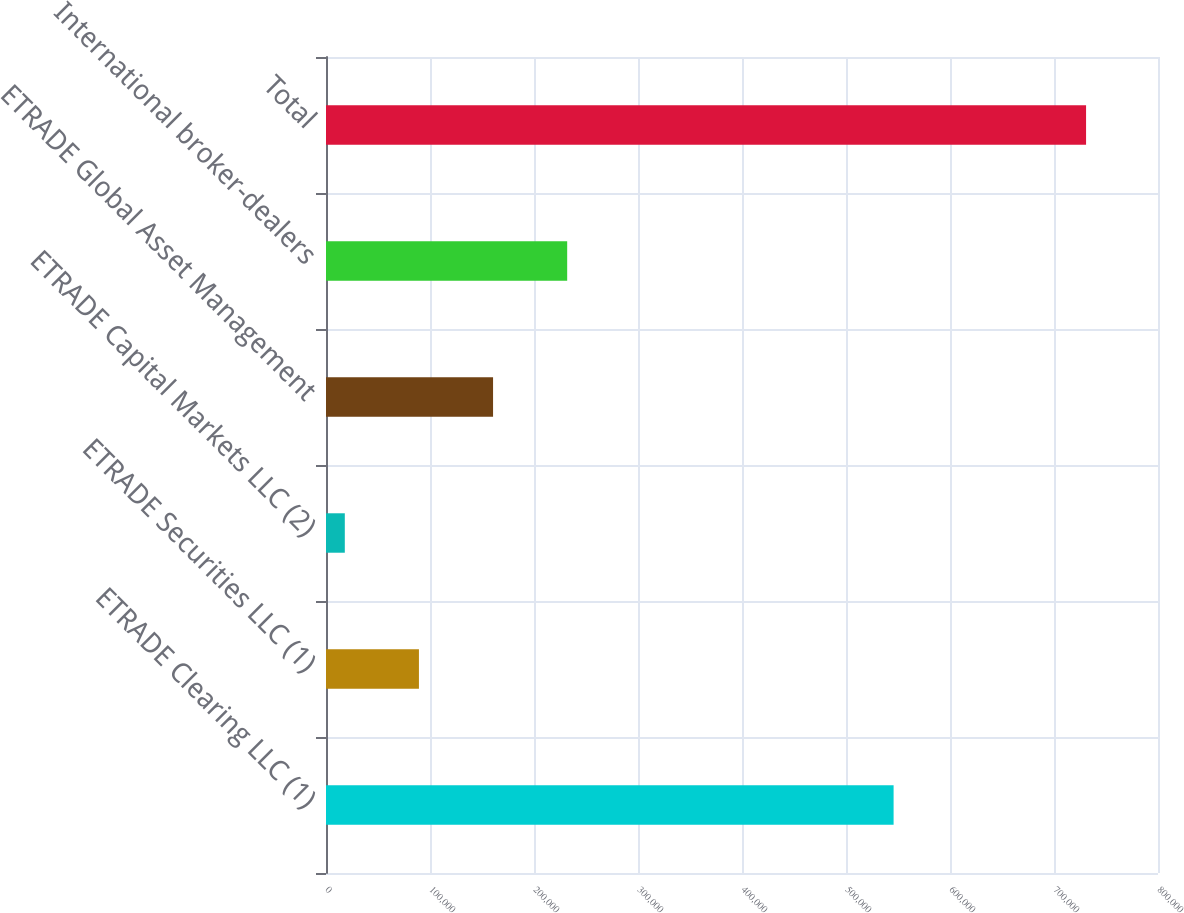<chart> <loc_0><loc_0><loc_500><loc_500><bar_chart><fcel>ETRADE Clearing LLC (1)<fcel>ETRADE Securities LLC (1)<fcel>ETRADE Capital Markets LLC (2)<fcel>ETRADE Global Asset Management<fcel>International broker-dealers<fcel>Total<nl><fcel>545769<fcel>89360.8<fcel>18086<fcel>160636<fcel>231910<fcel>730834<nl></chart> 